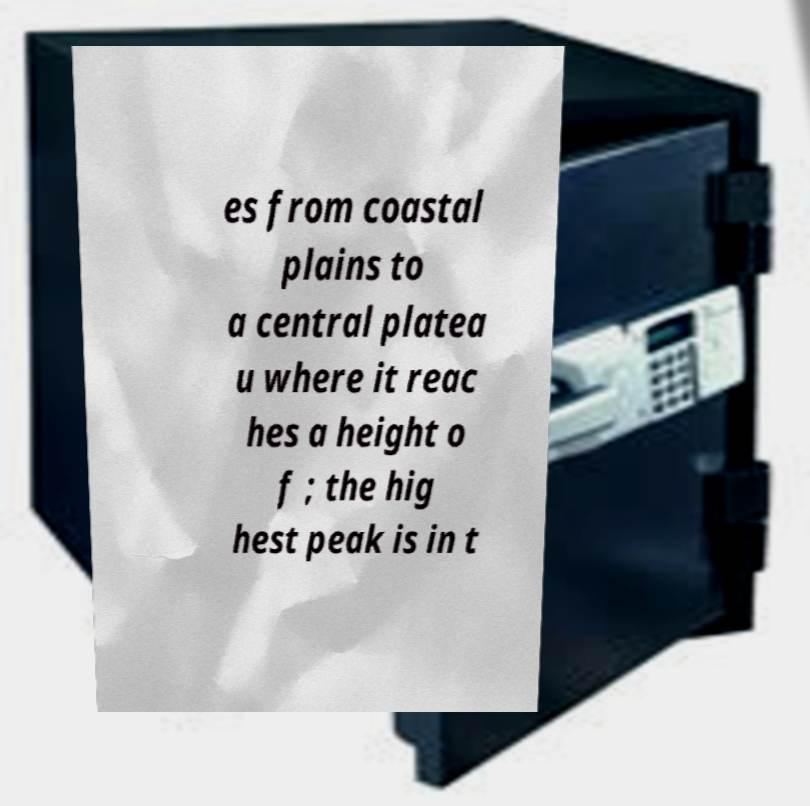What messages or text are displayed in this image? I need them in a readable, typed format. es from coastal plains to a central platea u where it reac hes a height o f ; the hig hest peak is in t 